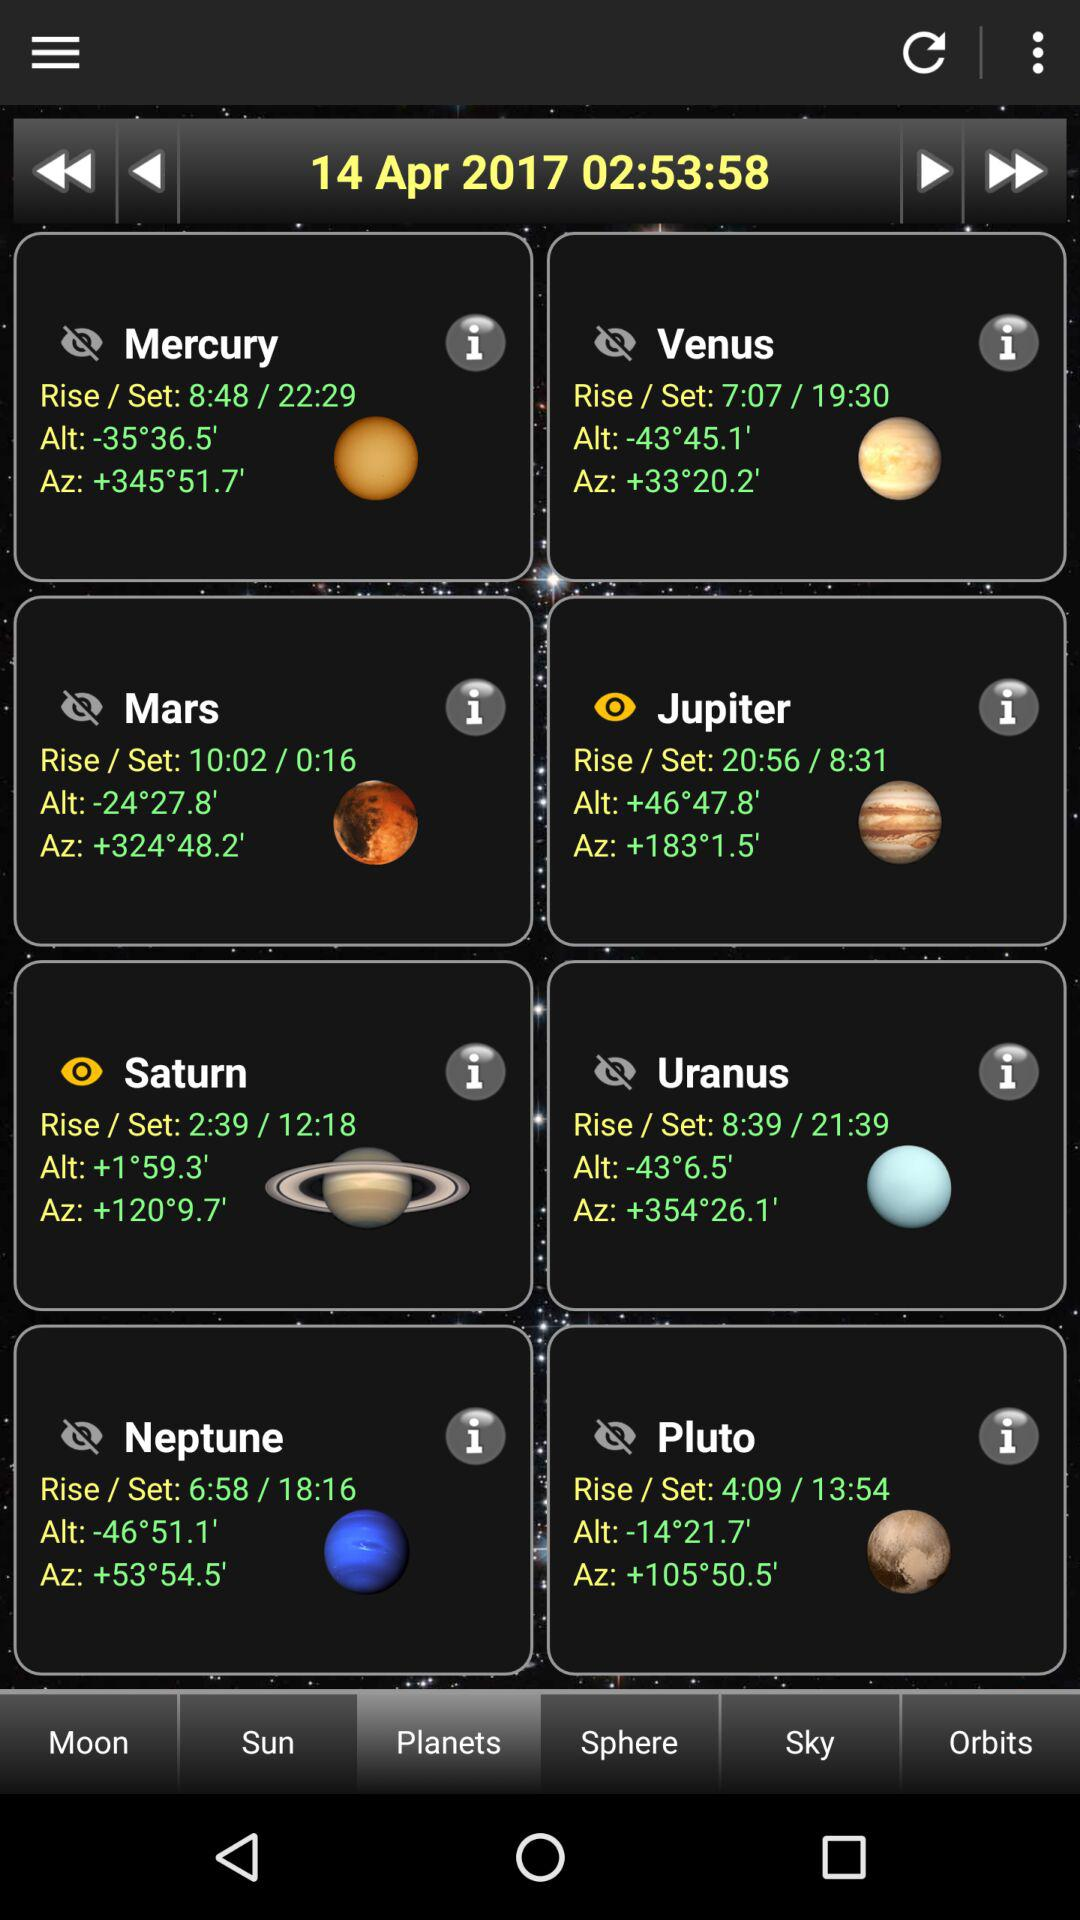Which tab is selected? The tab "Planets" is selected. 